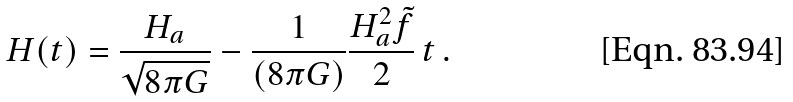Convert formula to latex. <formula><loc_0><loc_0><loc_500><loc_500>H ( t ) = \frac { H _ { a } } { \sqrt { 8 \pi G } } - \frac { 1 } { ( 8 \pi G ) } \frac { H _ { a } ^ { 2 } \tilde { f } } { 2 } \, t \, .</formula> 